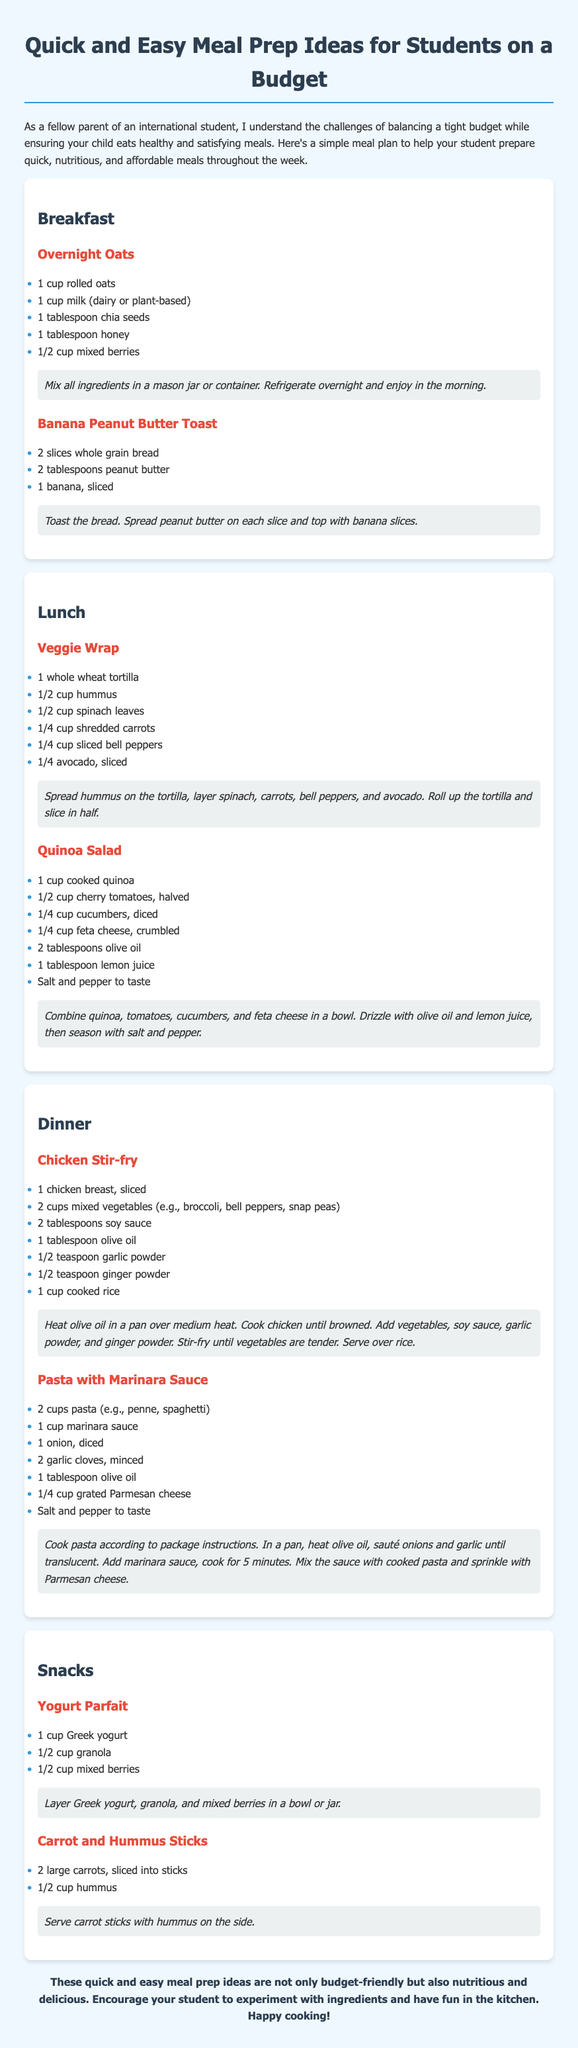What is the title of the document? The title of the document is mentioned in the header section as "Quick and Easy Meal Prep Ideas for Students on a Budget."
Answer: Quick and Easy Meal Prep Ideas for Students on a Budget How many breakfast meal ideas are listed? The document lists two breakfast meal ideas in the breakfast section.
Answer: 2 What ingredient is used in the Overnight Oats recipe? The ingredients for Overnight Oats include rolled oats, milk, chia seeds, honey, and mixed berries as listed in the breakfast section.
Answer: Rolled oats What is a key vegetable in the Chicken Stir-fry? The Chicken Stir-fry recipe includes mixed vegetables such as broccoli, bell peppers, and snap peas, which are all key elements.
Answer: Broccoli What is used for dressing in the Quinoa Salad? The dressing for the Quinoa Salad consists of olive oil and lemon juice, as specified in the salad recipe.
Answer: Olive oil What type of yogurt is used in the Yogurt Parfait? The Yogurt Parfait calls for Greek yogurt as the main type of yogurt used in the recipe.
Answer: Greek yogurt How is the Banana Peanut Butter Toast prepared? The Banana Peanut Butter Toast is prepared by toasting bread, spreading peanut butter, and topping with banana slices.
Answer: Toasted bread What is the total number of snack ideas provided? The document provides two snack ideas listed under the snacks section.
Answer: 2 